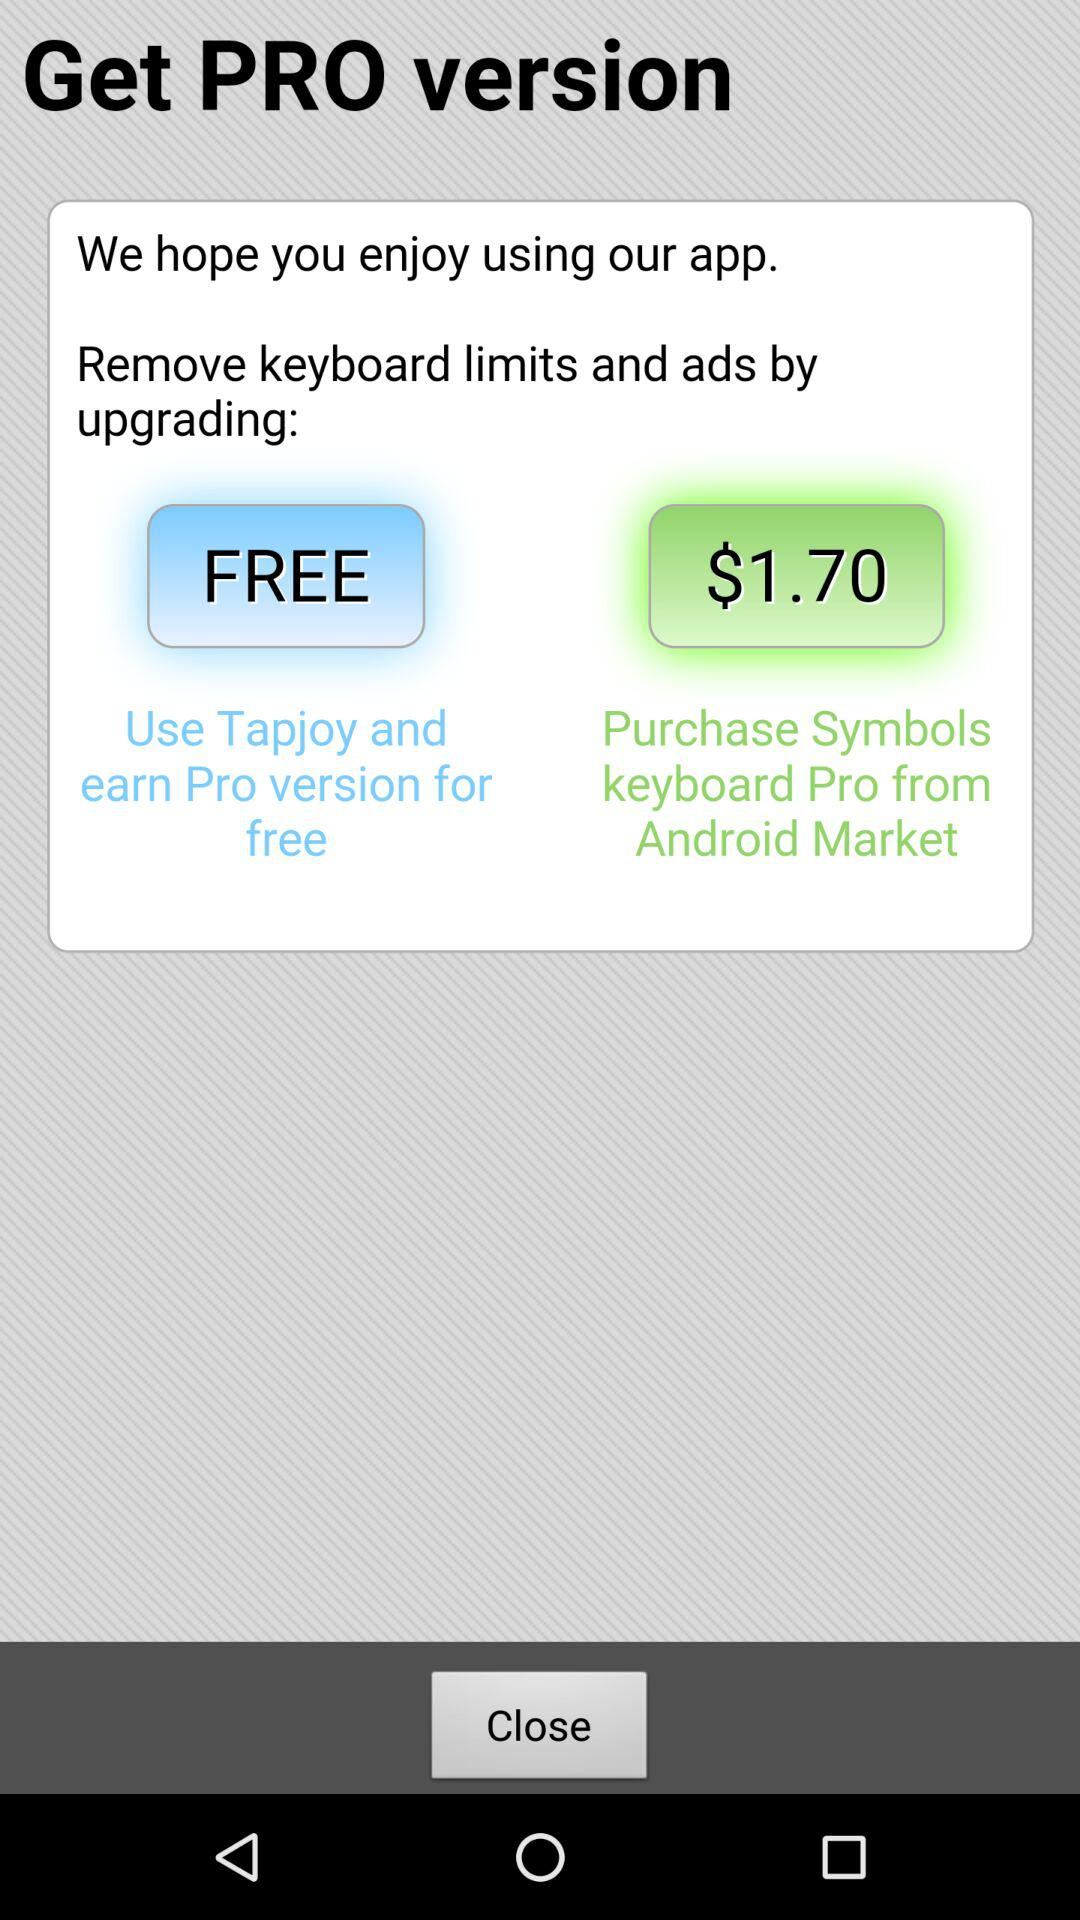How much can I purchase the pro version for? You can purchase the pro version for free. 